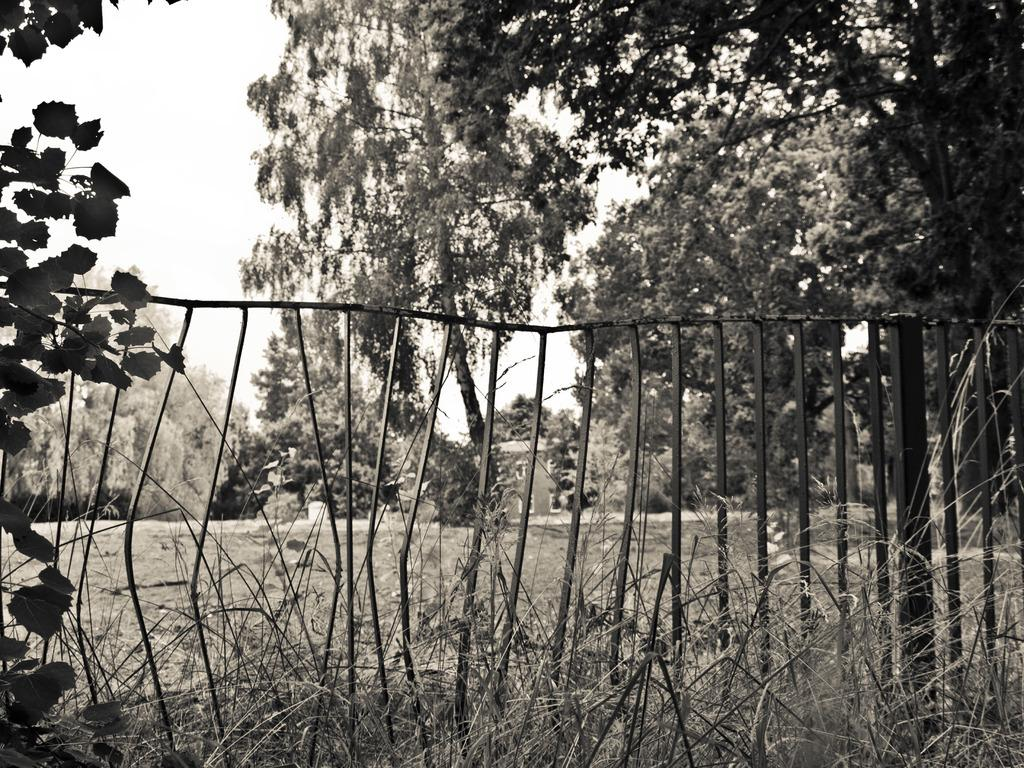What type of vegetation is present in the image? There are trees in the image. What type of ground cover is present in the image? There is grass in the image. What type of material is used for the railing in the image? There is metal railing in the image. What color scheme is used in the image? The image is in black and white. What type of learning is taking place in the image? There is no indication of learning or any educational activity in the image. What type of slope can be seen in the image? There is no slope present in the image; it features trees, grass, and metal railing. 